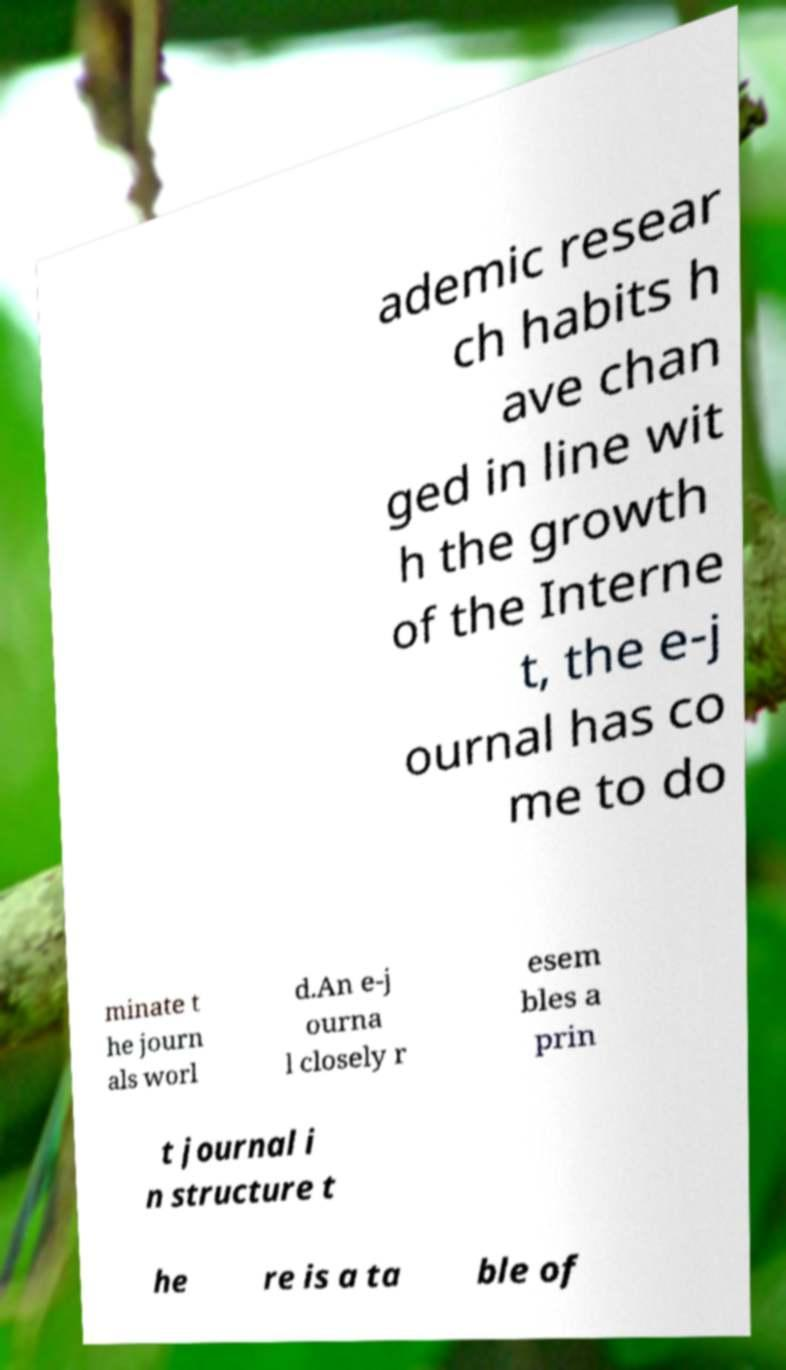Could you assist in decoding the text presented in this image and type it out clearly? ademic resear ch habits h ave chan ged in line wit h the growth of the Interne t, the e-j ournal has co me to do minate t he journ als worl d.An e-j ourna l closely r esem bles a prin t journal i n structure t he re is a ta ble of 